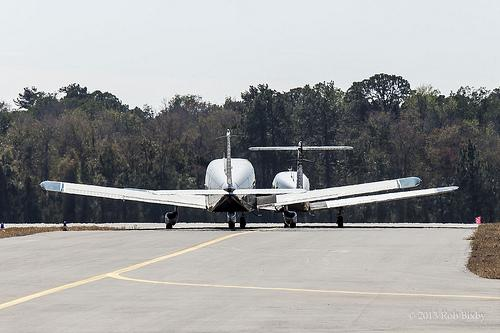Question: when was this picture taken?
Choices:
A. During the day.
B. At night.
C. On Christmas.
D. During the pageant.
Answer with the letter. Answer: A Question: what mode of transportation is pictured?
Choices:
A. Trains.
B. Automobiles.
C. Bicycles.
D. Airplanes.
Answer with the letter. Answer: D Question: how many airplanes are there?
Choices:
A. Three.
B. Two.
C. None.
D. One.
Answer with the letter. Answer: B Question: how many people are riding on elephants?
Choices:
A. One.
B. Zero.
C. Two.
D. Four.
Answer with the letter. Answer: B Question: where was this picture taken?
Choices:
A. At the train station.
B. At the bus terminal.
C. At the airport.
D. At the boatyard.
Answer with the letter. Answer: C 